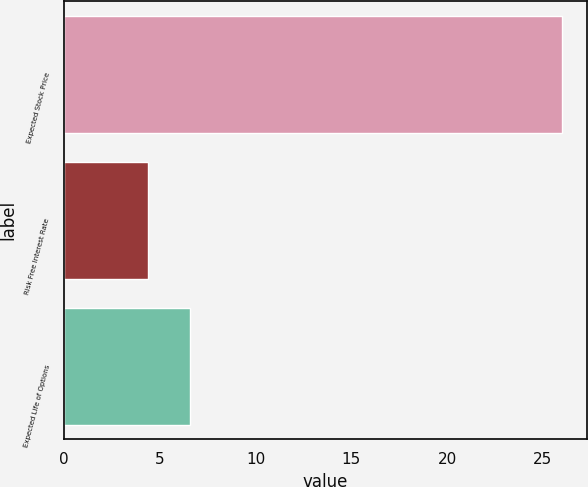<chart> <loc_0><loc_0><loc_500><loc_500><bar_chart><fcel>Expected Stock Price<fcel>Risk Free Interest Rate<fcel>Expected Life of Options<nl><fcel>26<fcel>4.4<fcel>6.56<nl></chart> 